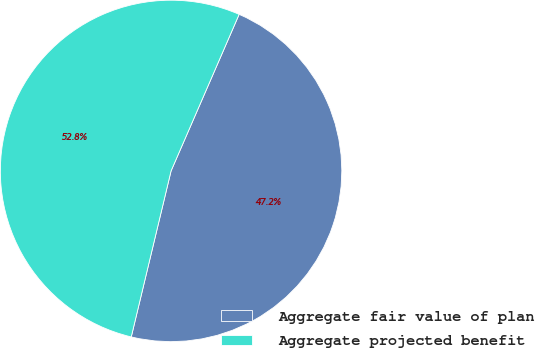<chart> <loc_0><loc_0><loc_500><loc_500><pie_chart><fcel>Aggregate fair value of plan<fcel>Aggregate projected benefit<nl><fcel>47.22%<fcel>52.78%<nl></chart> 